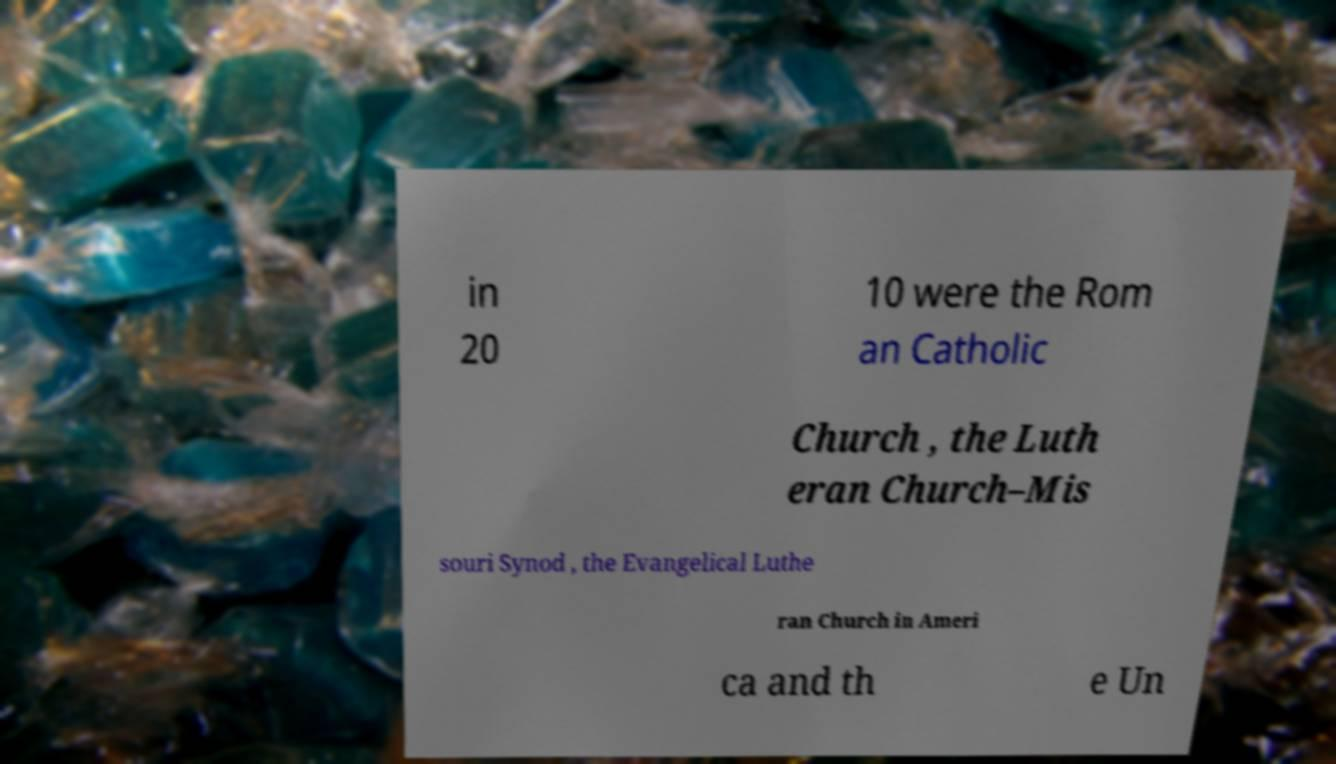Could you assist in decoding the text presented in this image and type it out clearly? in 20 10 were the Rom an Catholic Church , the Luth eran Church–Mis souri Synod , the Evangelical Luthe ran Church in Ameri ca and th e Un 